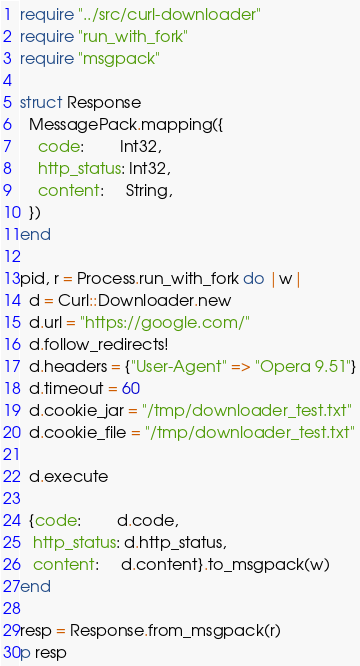<code> <loc_0><loc_0><loc_500><loc_500><_Crystal_>require "../src/curl-downloader"
require "run_with_fork"
require "msgpack"

struct Response
  MessagePack.mapping({
    code:        Int32,
    http_status: Int32,
    content:     String,
  })
end

pid, r = Process.run_with_fork do |w|
  d = Curl::Downloader.new
  d.url = "https://google.com/"
  d.follow_redirects!
  d.headers = {"User-Agent" => "Opera 9.51"}
  d.timeout = 60
  d.cookie_jar = "/tmp/downloader_test.txt"
  d.cookie_file = "/tmp/downloader_test.txt"

  d.execute

  {code:        d.code,
   http_status: d.http_status,
   content:     d.content}.to_msgpack(w)
end

resp = Response.from_msgpack(r)
p resp
</code> 